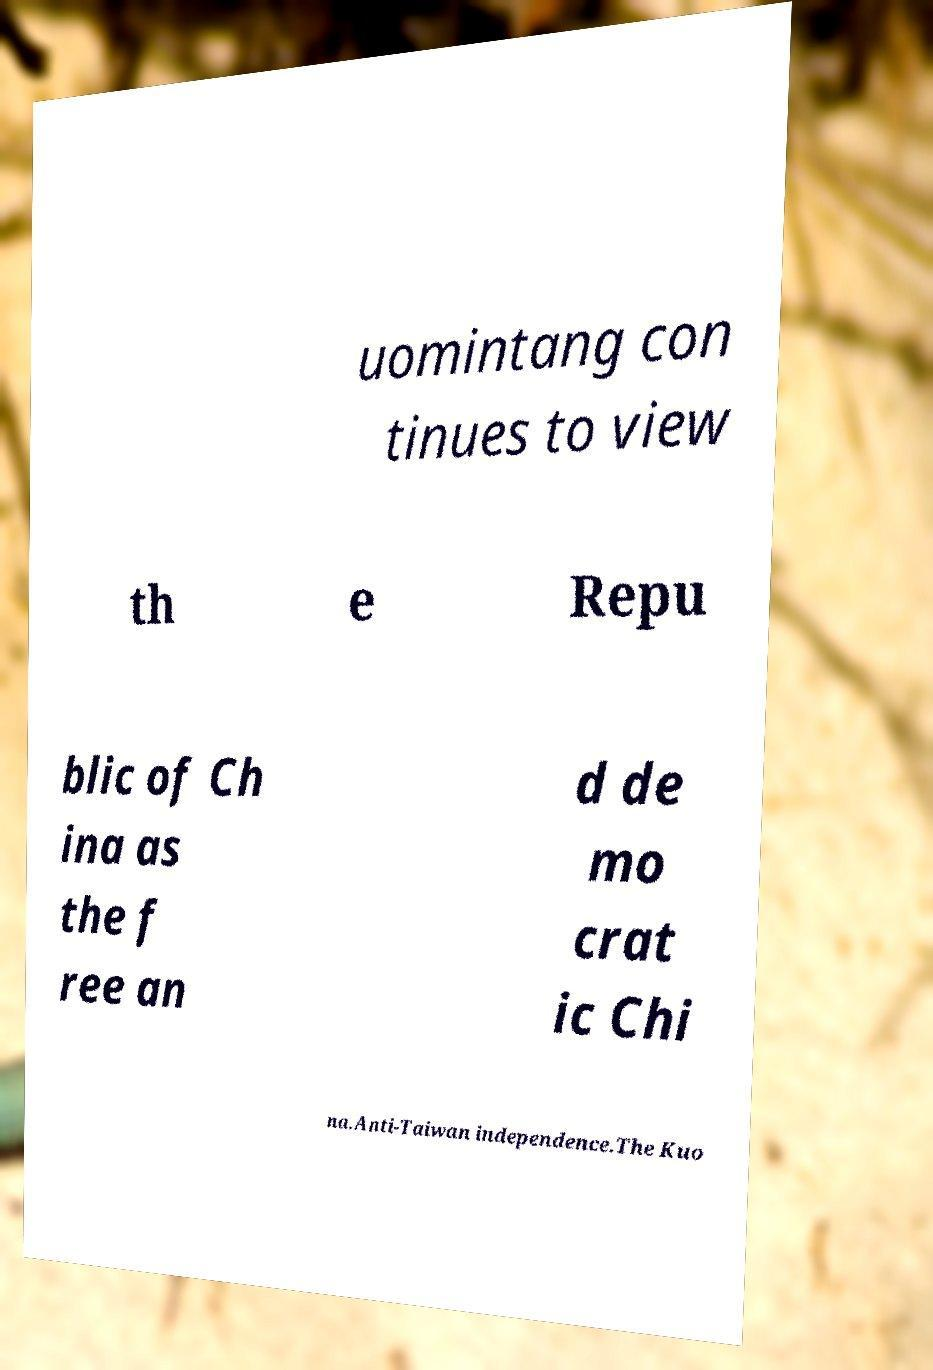Can you accurately transcribe the text from the provided image for me? uomintang con tinues to view th e Repu blic of Ch ina as the f ree an d de mo crat ic Chi na.Anti-Taiwan independence.The Kuo 